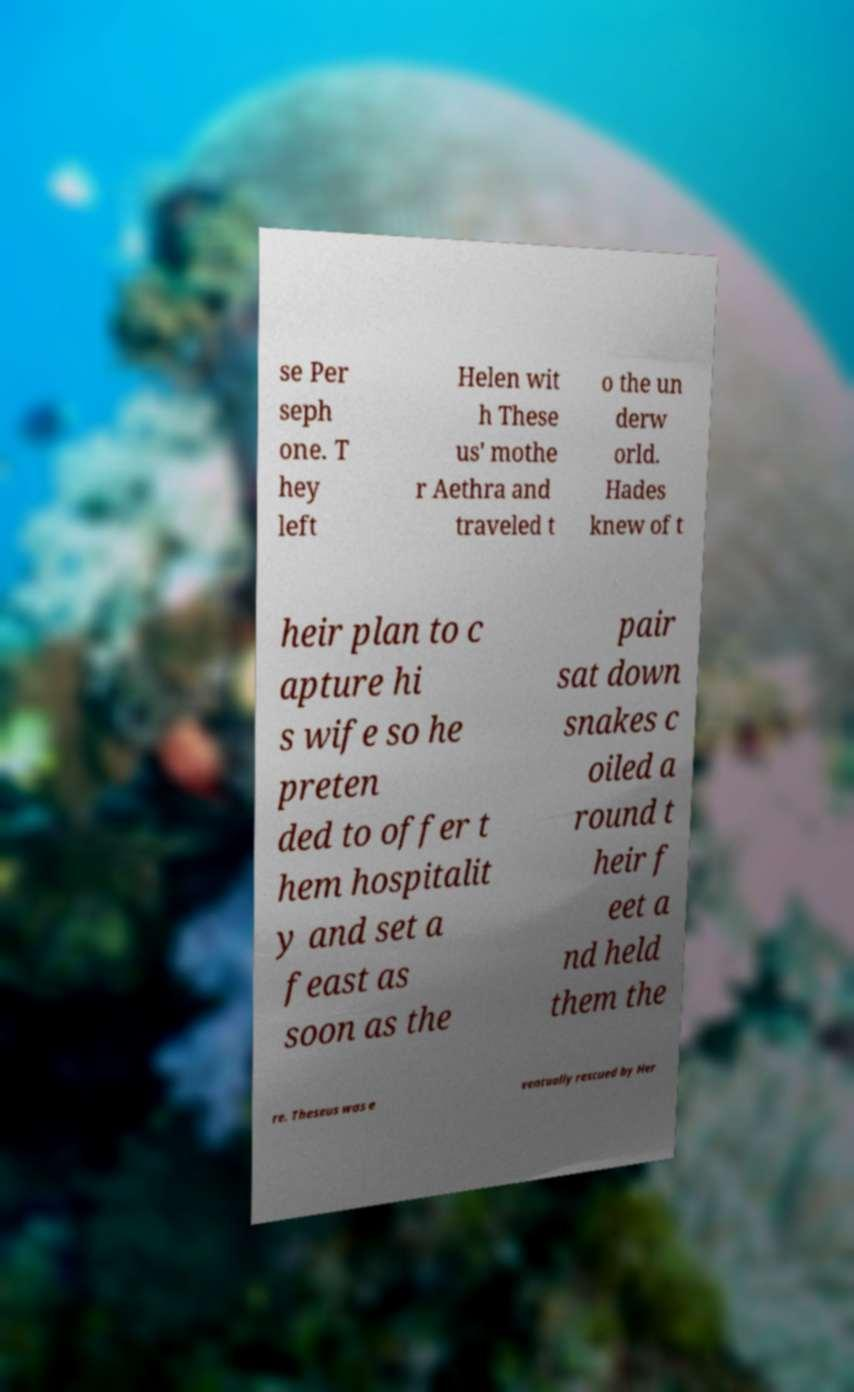Please read and relay the text visible in this image. What does it say? se Per seph one. T hey left Helen wit h These us' mothe r Aethra and traveled t o the un derw orld. Hades knew of t heir plan to c apture hi s wife so he preten ded to offer t hem hospitalit y and set a feast as soon as the pair sat down snakes c oiled a round t heir f eet a nd held them the re. Theseus was e ventually rescued by Her 